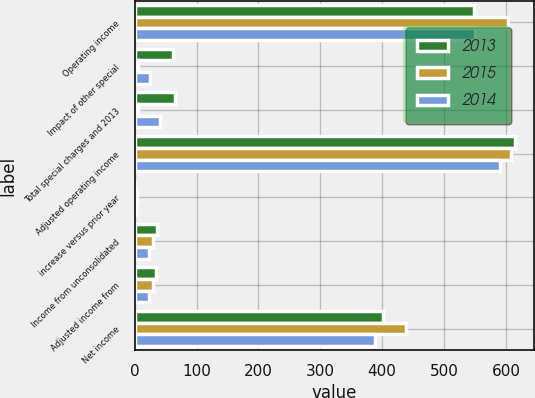Convert chart. <chart><loc_0><loc_0><loc_500><loc_500><stacked_bar_chart><ecel><fcel>Operating income<fcel>Impact of other special<fcel>Total special charges and 2013<fcel>Adjusted operating income<fcel>increase versus prior year<fcel>Income from unconsolidated<fcel>Adjusted income from<fcel>Net income<nl><fcel>2013<fcel>548.4<fcel>61.5<fcel>65.5<fcel>613.9<fcel>0.9<fcel>36.7<fcel>34.7<fcel>401.6<nl><fcel>2015<fcel>603<fcel>5.2<fcel>5.2<fcel>608.2<fcel>2.9<fcel>29.4<fcel>29.4<fcel>437.9<nl><fcel>2014<fcel>550.5<fcel>25<fcel>40.3<fcel>590.8<fcel>2.2<fcel>23.2<fcel>23.2<fcel>389<nl></chart> 